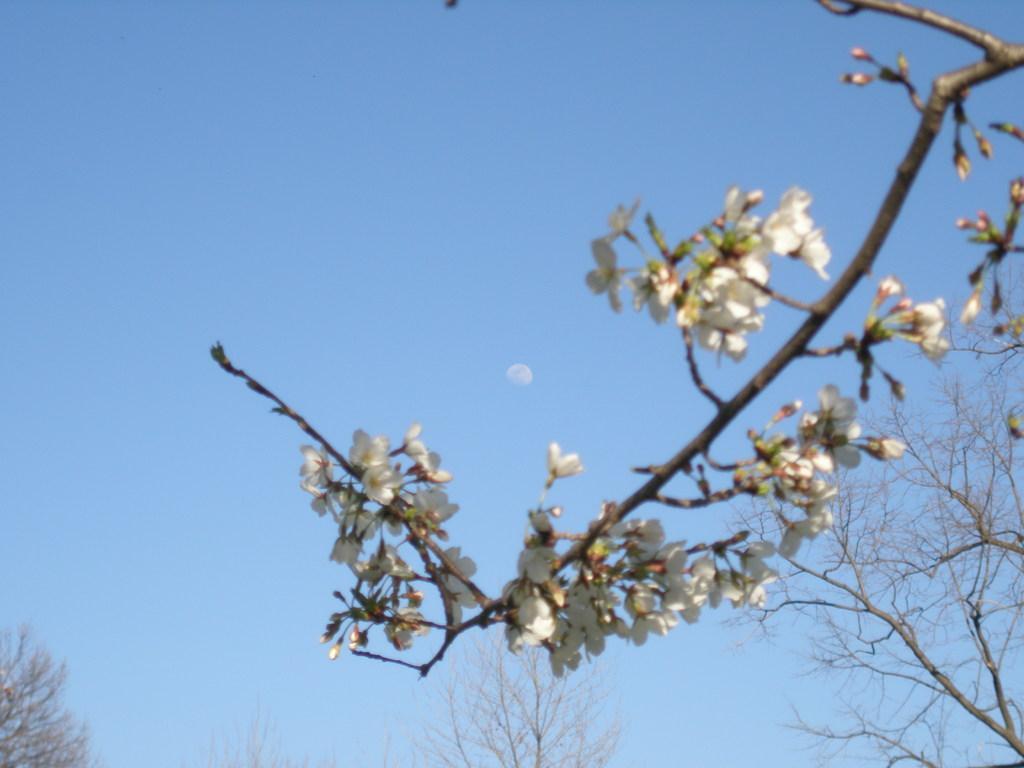Could you give a brief overview of what you see in this image? In the foreground of the picture there are flowers and stem. In the center of the picture there are trees. In the background it is sky. In the center of the sky there is an object. 